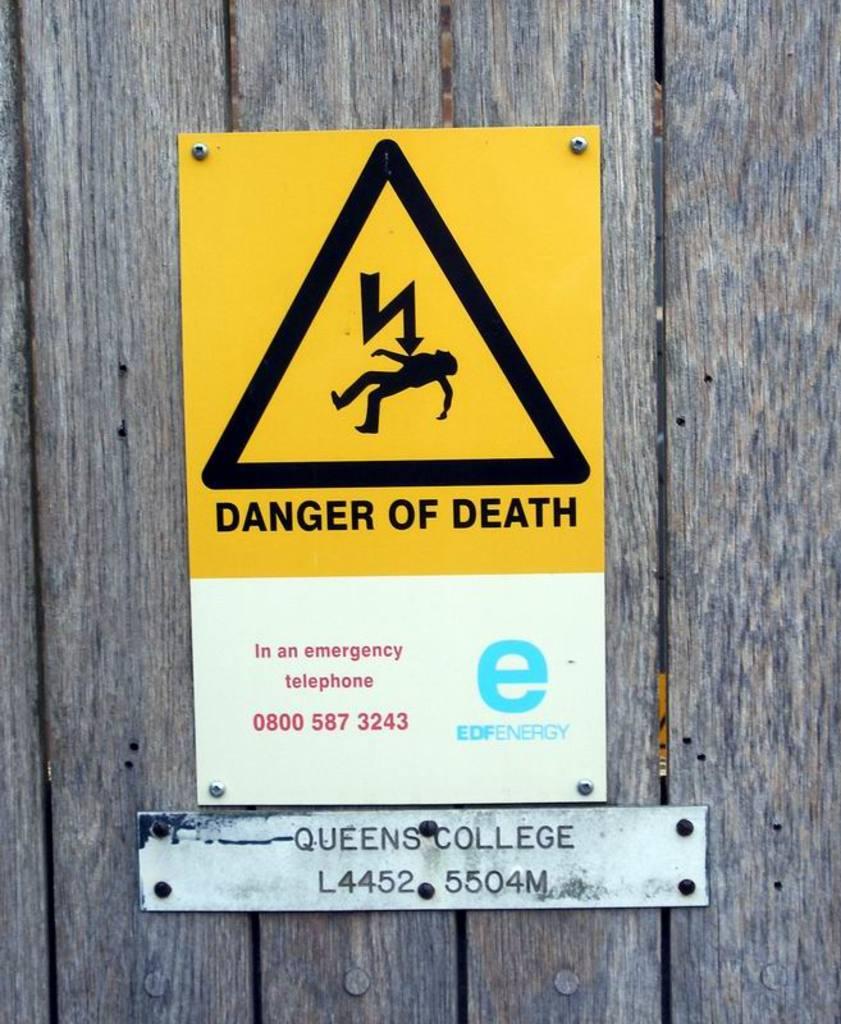What does this sign warn against?
Make the answer very short. Death. What telephone number is shown on danger of death sign?
Keep it short and to the point. 0800 587 3243. 